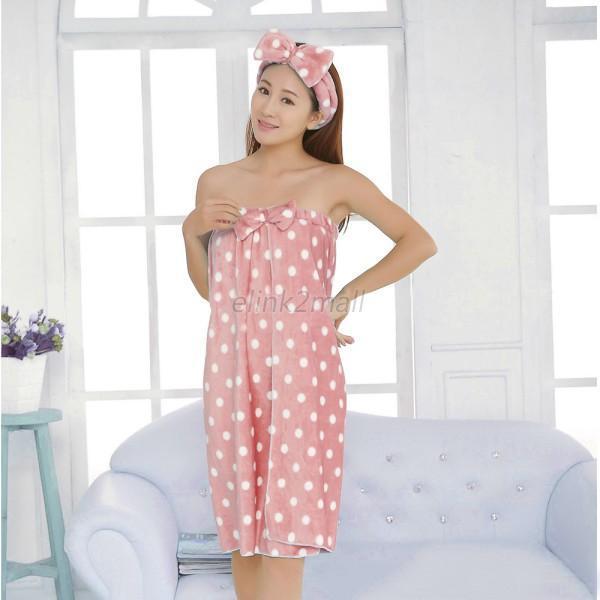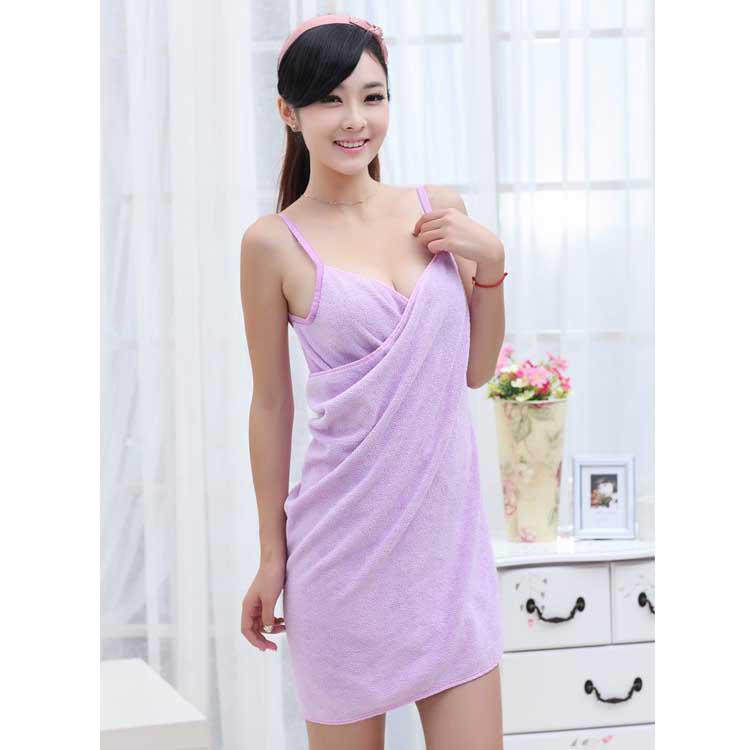The first image is the image on the left, the second image is the image on the right. Considering the images on both sides, is "One woman's towel is pink with white polka dots." valid? Answer yes or no. Yes. The first image is the image on the left, the second image is the image on the right. Analyze the images presented: Is the assertion "At least one of the women has her hand to her face." valid? Answer yes or no. No. 